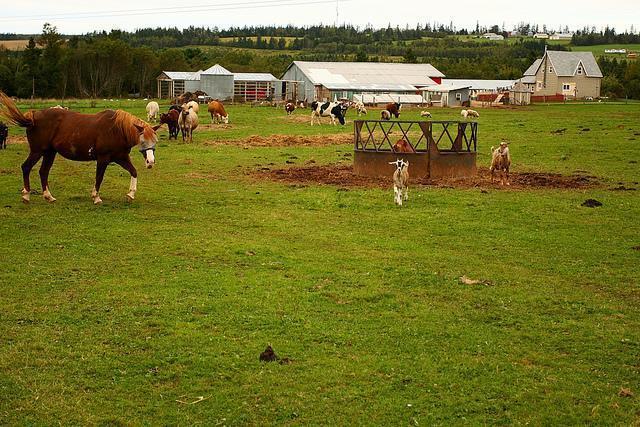How many goats do you see directly facing the camera?
Give a very brief answer. 2. 